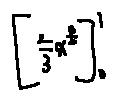<formula> <loc_0><loc_0><loc_500><loc_500>[ \frac { 2 } { 3 } x ^ { \frac { 3 } { 2 } } ] _ { 0 } ^ { 1 }</formula> 